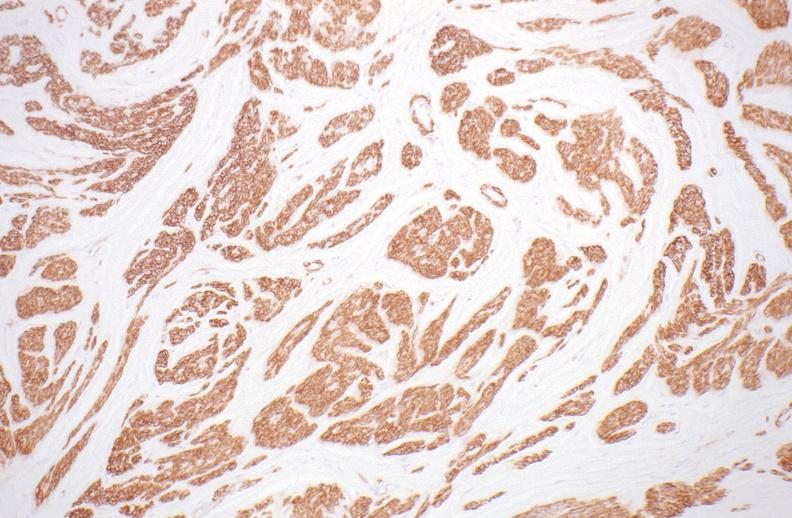s female reproductive present?
Answer the question using a single word or phrase. Yes 